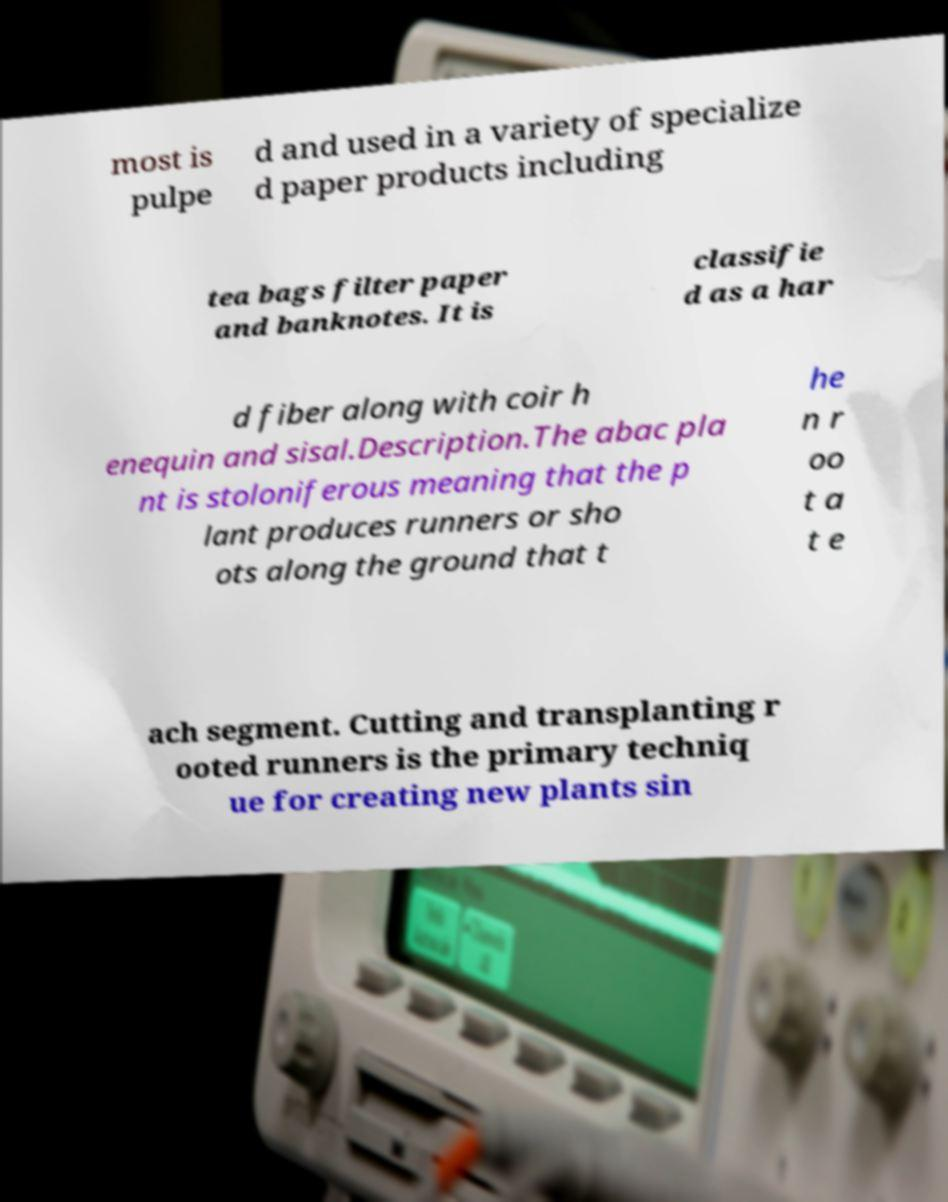I need the written content from this picture converted into text. Can you do that? most is pulpe d and used in a variety of specialize d paper products including tea bags filter paper and banknotes. It is classifie d as a har d fiber along with coir h enequin and sisal.Description.The abac pla nt is stoloniferous meaning that the p lant produces runners or sho ots along the ground that t he n r oo t a t e ach segment. Cutting and transplanting r ooted runners is the primary techniq ue for creating new plants sin 